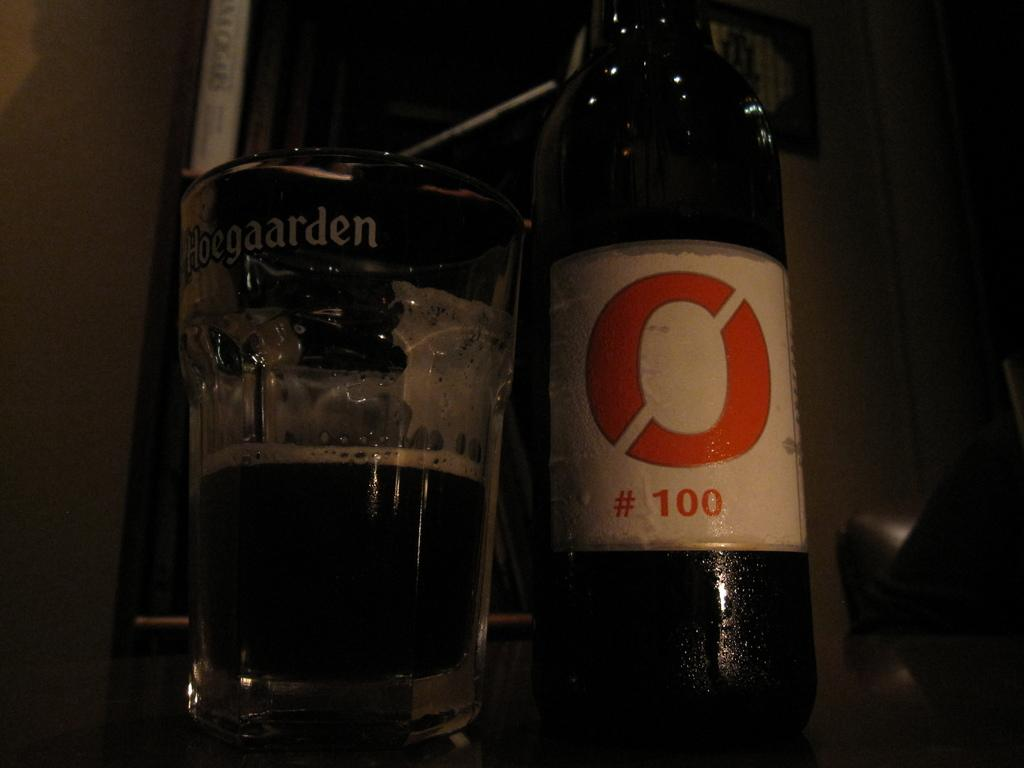<image>
Present a compact description of the photo's key features. a glass of hoegarden and a bottle with #100 